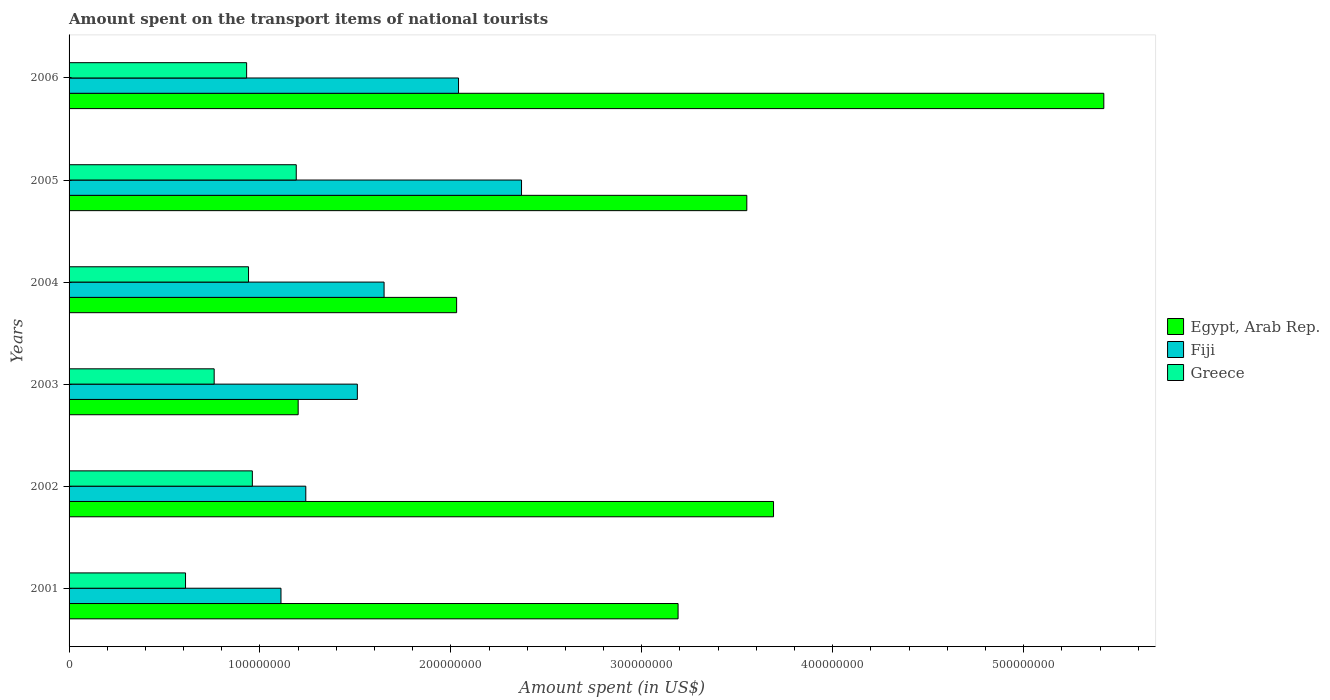How many groups of bars are there?
Provide a succinct answer. 6. How many bars are there on the 5th tick from the top?
Your answer should be compact. 3. What is the label of the 6th group of bars from the top?
Make the answer very short. 2001. What is the amount spent on the transport items of national tourists in Egypt, Arab Rep. in 2003?
Your answer should be compact. 1.20e+08. Across all years, what is the maximum amount spent on the transport items of national tourists in Egypt, Arab Rep.?
Provide a succinct answer. 5.42e+08. Across all years, what is the minimum amount spent on the transport items of national tourists in Egypt, Arab Rep.?
Provide a short and direct response. 1.20e+08. What is the total amount spent on the transport items of national tourists in Fiji in the graph?
Make the answer very short. 9.92e+08. What is the difference between the amount spent on the transport items of national tourists in Egypt, Arab Rep. in 2002 and that in 2005?
Offer a very short reply. 1.40e+07. What is the difference between the amount spent on the transport items of national tourists in Egypt, Arab Rep. in 2004 and the amount spent on the transport items of national tourists in Greece in 2002?
Provide a short and direct response. 1.07e+08. What is the average amount spent on the transport items of national tourists in Egypt, Arab Rep. per year?
Ensure brevity in your answer.  3.18e+08. In the year 2004, what is the difference between the amount spent on the transport items of national tourists in Egypt, Arab Rep. and amount spent on the transport items of national tourists in Fiji?
Ensure brevity in your answer.  3.80e+07. In how many years, is the amount spent on the transport items of national tourists in Egypt, Arab Rep. greater than 40000000 US$?
Provide a short and direct response. 6. What is the ratio of the amount spent on the transport items of national tourists in Egypt, Arab Rep. in 2003 to that in 2005?
Give a very brief answer. 0.34. Is the amount spent on the transport items of national tourists in Fiji in 2003 less than that in 2004?
Keep it short and to the point. Yes. What is the difference between the highest and the second highest amount spent on the transport items of national tourists in Greece?
Keep it short and to the point. 2.30e+07. What is the difference between the highest and the lowest amount spent on the transport items of national tourists in Greece?
Provide a short and direct response. 5.80e+07. In how many years, is the amount spent on the transport items of national tourists in Fiji greater than the average amount spent on the transport items of national tourists in Fiji taken over all years?
Your response must be concise. 2. What does the 3rd bar from the top in 2005 represents?
Your response must be concise. Egypt, Arab Rep. What does the 2nd bar from the bottom in 2001 represents?
Your answer should be compact. Fiji. Are all the bars in the graph horizontal?
Make the answer very short. Yes. How many years are there in the graph?
Offer a terse response. 6. Does the graph contain any zero values?
Give a very brief answer. No. Does the graph contain grids?
Ensure brevity in your answer.  No. Where does the legend appear in the graph?
Ensure brevity in your answer.  Center right. What is the title of the graph?
Make the answer very short. Amount spent on the transport items of national tourists. Does "Georgia" appear as one of the legend labels in the graph?
Offer a very short reply. No. What is the label or title of the X-axis?
Your answer should be compact. Amount spent (in US$). What is the Amount spent (in US$) in Egypt, Arab Rep. in 2001?
Ensure brevity in your answer.  3.19e+08. What is the Amount spent (in US$) of Fiji in 2001?
Offer a very short reply. 1.11e+08. What is the Amount spent (in US$) in Greece in 2001?
Offer a very short reply. 6.10e+07. What is the Amount spent (in US$) of Egypt, Arab Rep. in 2002?
Make the answer very short. 3.69e+08. What is the Amount spent (in US$) of Fiji in 2002?
Your answer should be very brief. 1.24e+08. What is the Amount spent (in US$) in Greece in 2002?
Give a very brief answer. 9.60e+07. What is the Amount spent (in US$) in Egypt, Arab Rep. in 2003?
Your answer should be compact. 1.20e+08. What is the Amount spent (in US$) in Fiji in 2003?
Your answer should be very brief. 1.51e+08. What is the Amount spent (in US$) of Greece in 2003?
Offer a terse response. 7.60e+07. What is the Amount spent (in US$) in Egypt, Arab Rep. in 2004?
Your answer should be very brief. 2.03e+08. What is the Amount spent (in US$) in Fiji in 2004?
Your response must be concise. 1.65e+08. What is the Amount spent (in US$) of Greece in 2004?
Your answer should be very brief. 9.40e+07. What is the Amount spent (in US$) of Egypt, Arab Rep. in 2005?
Ensure brevity in your answer.  3.55e+08. What is the Amount spent (in US$) of Fiji in 2005?
Keep it short and to the point. 2.37e+08. What is the Amount spent (in US$) of Greece in 2005?
Keep it short and to the point. 1.19e+08. What is the Amount spent (in US$) of Egypt, Arab Rep. in 2006?
Your response must be concise. 5.42e+08. What is the Amount spent (in US$) in Fiji in 2006?
Provide a succinct answer. 2.04e+08. What is the Amount spent (in US$) in Greece in 2006?
Keep it short and to the point. 9.30e+07. Across all years, what is the maximum Amount spent (in US$) in Egypt, Arab Rep.?
Provide a short and direct response. 5.42e+08. Across all years, what is the maximum Amount spent (in US$) in Fiji?
Ensure brevity in your answer.  2.37e+08. Across all years, what is the maximum Amount spent (in US$) of Greece?
Keep it short and to the point. 1.19e+08. Across all years, what is the minimum Amount spent (in US$) of Egypt, Arab Rep.?
Provide a short and direct response. 1.20e+08. Across all years, what is the minimum Amount spent (in US$) in Fiji?
Your answer should be compact. 1.11e+08. Across all years, what is the minimum Amount spent (in US$) in Greece?
Your answer should be very brief. 6.10e+07. What is the total Amount spent (in US$) in Egypt, Arab Rep. in the graph?
Make the answer very short. 1.91e+09. What is the total Amount spent (in US$) of Fiji in the graph?
Offer a very short reply. 9.92e+08. What is the total Amount spent (in US$) in Greece in the graph?
Offer a terse response. 5.39e+08. What is the difference between the Amount spent (in US$) of Egypt, Arab Rep. in 2001 and that in 2002?
Keep it short and to the point. -5.00e+07. What is the difference between the Amount spent (in US$) of Fiji in 2001 and that in 2002?
Make the answer very short. -1.30e+07. What is the difference between the Amount spent (in US$) in Greece in 2001 and that in 2002?
Give a very brief answer. -3.50e+07. What is the difference between the Amount spent (in US$) of Egypt, Arab Rep. in 2001 and that in 2003?
Your response must be concise. 1.99e+08. What is the difference between the Amount spent (in US$) in Fiji in 2001 and that in 2003?
Give a very brief answer. -4.00e+07. What is the difference between the Amount spent (in US$) in Greece in 2001 and that in 2003?
Ensure brevity in your answer.  -1.50e+07. What is the difference between the Amount spent (in US$) in Egypt, Arab Rep. in 2001 and that in 2004?
Keep it short and to the point. 1.16e+08. What is the difference between the Amount spent (in US$) of Fiji in 2001 and that in 2004?
Give a very brief answer. -5.40e+07. What is the difference between the Amount spent (in US$) of Greece in 2001 and that in 2004?
Offer a very short reply. -3.30e+07. What is the difference between the Amount spent (in US$) in Egypt, Arab Rep. in 2001 and that in 2005?
Your answer should be compact. -3.60e+07. What is the difference between the Amount spent (in US$) in Fiji in 2001 and that in 2005?
Offer a very short reply. -1.26e+08. What is the difference between the Amount spent (in US$) of Greece in 2001 and that in 2005?
Your answer should be compact. -5.80e+07. What is the difference between the Amount spent (in US$) of Egypt, Arab Rep. in 2001 and that in 2006?
Make the answer very short. -2.23e+08. What is the difference between the Amount spent (in US$) in Fiji in 2001 and that in 2006?
Make the answer very short. -9.30e+07. What is the difference between the Amount spent (in US$) in Greece in 2001 and that in 2006?
Make the answer very short. -3.20e+07. What is the difference between the Amount spent (in US$) in Egypt, Arab Rep. in 2002 and that in 2003?
Make the answer very short. 2.49e+08. What is the difference between the Amount spent (in US$) in Fiji in 2002 and that in 2003?
Give a very brief answer. -2.70e+07. What is the difference between the Amount spent (in US$) of Greece in 2002 and that in 2003?
Offer a terse response. 2.00e+07. What is the difference between the Amount spent (in US$) of Egypt, Arab Rep. in 2002 and that in 2004?
Provide a short and direct response. 1.66e+08. What is the difference between the Amount spent (in US$) in Fiji in 2002 and that in 2004?
Make the answer very short. -4.10e+07. What is the difference between the Amount spent (in US$) of Greece in 2002 and that in 2004?
Offer a very short reply. 2.00e+06. What is the difference between the Amount spent (in US$) of Egypt, Arab Rep. in 2002 and that in 2005?
Your response must be concise. 1.40e+07. What is the difference between the Amount spent (in US$) in Fiji in 2002 and that in 2005?
Provide a succinct answer. -1.13e+08. What is the difference between the Amount spent (in US$) of Greece in 2002 and that in 2005?
Provide a short and direct response. -2.30e+07. What is the difference between the Amount spent (in US$) in Egypt, Arab Rep. in 2002 and that in 2006?
Make the answer very short. -1.73e+08. What is the difference between the Amount spent (in US$) in Fiji in 2002 and that in 2006?
Offer a very short reply. -8.00e+07. What is the difference between the Amount spent (in US$) of Egypt, Arab Rep. in 2003 and that in 2004?
Your response must be concise. -8.30e+07. What is the difference between the Amount spent (in US$) of Fiji in 2003 and that in 2004?
Make the answer very short. -1.40e+07. What is the difference between the Amount spent (in US$) of Greece in 2003 and that in 2004?
Offer a terse response. -1.80e+07. What is the difference between the Amount spent (in US$) in Egypt, Arab Rep. in 2003 and that in 2005?
Your response must be concise. -2.35e+08. What is the difference between the Amount spent (in US$) in Fiji in 2003 and that in 2005?
Make the answer very short. -8.60e+07. What is the difference between the Amount spent (in US$) of Greece in 2003 and that in 2005?
Your answer should be compact. -4.30e+07. What is the difference between the Amount spent (in US$) in Egypt, Arab Rep. in 2003 and that in 2006?
Provide a succinct answer. -4.22e+08. What is the difference between the Amount spent (in US$) in Fiji in 2003 and that in 2006?
Your answer should be very brief. -5.30e+07. What is the difference between the Amount spent (in US$) in Greece in 2003 and that in 2006?
Your response must be concise. -1.70e+07. What is the difference between the Amount spent (in US$) in Egypt, Arab Rep. in 2004 and that in 2005?
Give a very brief answer. -1.52e+08. What is the difference between the Amount spent (in US$) of Fiji in 2004 and that in 2005?
Ensure brevity in your answer.  -7.20e+07. What is the difference between the Amount spent (in US$) of Greece in 2004 and that in 2005?
Provide a short and direct response. -2.50e+07. What is the difference between the Amount spent (in US$) in Egypt, Arab Rep. in 2004 and that in 2006?
Your answer should be compact. -3.39e+08. What is the difference between the Amount spent (in US$) of Fiji in 2004 and that in 2006?
Your answer should be very brief. -3.90e+07. What is the difference between the Amount spent (in US$) of Egypt, Arab Rep. in 2005 and that in 2006?
Offer a very short reply. -1.87e+08. What is the difference between the Amount spent (in US$) in Fiji in 2005 and that in 2006?
Keep it short and to the point. 3.30e+07. What is the difference between the Amount spent (in US$) in Greece in 2005 and that in 2006?
Your answer should be very brief. 2.60e+07. What is the difference between the Amount spent (in US$) of Egypt, Arab Rep. in 2001 and the Amount spent (in US$) of Fiji in 2002?
Your answer should be compact. 1.95e+08. What is the difference between the Amount spent (in US$) in Egypt, Arab Rep. in 2001 and the Amount spent (in US$) in Greece in 2002?
Offer a very short reply. 2.23e+08. What is the difference between the Amount spent (in US$) in Fiji in 2001 and the Amount spent (in US$) in Greece in 2002?
Provide a short and direct response. 1.50e+07. What is the difference between the Amount spent (in US$) in Egypt, Arab Rep. in 2001 and the Amount spent (in US$) in Fiji in 2003?
Give a very brief answer. 1.68e+08. What is the difference between the Amount spent (in US$) of Egypt, Arab Rep. in 2001 and the Amount spent (in US$) of Greece in 2003?
Your answer should be compact. 2.43e+08. What is the difference between the Amount spent (in US$) in Fiji in 2001 and the Amount spent (in US$) in Greece in 2003?
Ensure brevity in your answer.  3.50e+07. What is the difference between the Amount spent (in US$) in Egypt, Arab Rep. in 2001 and the Amount spent (in US$) in Fiji in 2004?
Give a very brief answer. 1.54e+08. What is the difference between the Amount spent (in US$) of Egypt, Arab Rep. in 2001 and the Amount spent (in US$) of Greece in 2004?
Provide a succinct answer. 2.25e+08. What is the difference between the Amount spent (in US$) in Fiji in 2001 and the Amount spent (in US$) in Greece in 2004?
Make the answer very short. 1.70e+07. What is the difference between the Amount spent (in US$) of Egypt, Arab Rep. in 2001 and the Amount spent (in US$) of Fiji in 2005?
Your response must be concise. 8.20e+07. What is the difference between the Amount spent (in US$) in Fiji in 2001 and the Amount spent (in US$) in Greece in 2005?
Provide a succinct answer. -8.00e+06. What is the difference between the Amount spent (in US$) of Egypt, Arab Rep. in 2001 and the Amount spent (in US$) of Fiji in 2006?
Offer a terse response. 1.15e+08. What is the difference between the Amount spent (in US$) in Egypt, Arab Rep. in 2001 and the Amount spent (in US$) in Greece in 2006?
Your answer should be compact. 2.26e+08. What is the difference between the Amount spent (in US$) in Fiji in 2001 and the Amount spent (in US$) in Greece in 2006?
Offer a very short reply. 1.80e+07. What is the difference between the Amount spent (in US$) in Egypt, Arab Rep. in 2002 and the Amount spent (in US$) in Fiji in 2003?
Keep it short and to the point. 2.18e+08. What is the difference between the Amount spent (in US$) in Egypt, Arab Rep. in 2002 and the Amount spent (in US$) in Greece in 2003?
Provide a short and direct response. 2.93e+08. What is the difference between the Amount spent (in US$) of Fiji in 2002 and the Amount spent (in US$) of Greece in 2003?
Your answer should be very brief. 4.80e+07. What is the difference between the Amount spent (in US$) in Egypt, Arab Rep. in 2002 and the Amount spent (in US$) in Fiji in 2004?
Offer a very short reply. 2.04e+08. What is the difference between the Amount spent (in US$) in Egypt, Arab Rep. in 2002 and the Amount spent (in US$) in Greece in 2004?
Your answer should be compact. 2.75e+08. What is the difference between the Amount spent (in US$) in Fiji in 2002 and the Amount spent (in US$) in Greece in 2004?
Make the answer very short. 3.00e+07. What is the difference between the Amount spent (in US$) in Egypt, Arab Rep. in 2002 and the Amount spent (in US$) in Fiji in 2005?
Give a very brief answer. 1.32e+08. What is the difference between the Amount spent (in US$) of Egypt, Arab Rep. in 2002 and the Amount spent (in US$) of Greece in 2005?
Offer a terse response. 2.50e+08. What is the difference between the Amount spent (in US$) of Egypt, Arab Rep. in 2002 and the Amount spent (in US$) of Fiji in 2006?
Keep it short and to the point. 1.65e+08. What is the difference between the Amount spent (in US$) in Egypt, Arab Rep. in 2002 and the Amount spent (in US$) in Greece in 2006?
Your response must be concise. 2.76e+08. What is the difference between the Amount spent (in US$) in Fiji in 2002 and the Amount spent (in US$) in Greece in 2006?
Offer a terse response. 3.10e+07. What is the difference between the Amount spent (in US$) in Egypt, Arab Rep. in 2003 and the Amount spent (in US$) in Fiji in 2004?
Give a very brief answer. -4.50e+07. What is the difference between the Amount spent (in US$) in Egypt, Arab Rep. in 2003 and the Amount spent (in US$) in Greece in 2004?
Your answer should be compact. 2.60e+07. What is the difference between the Amount spent (in US$) in Fiji in 2003 and the Amount spent (in US$) in Greece in 2004?
Keep it short and to the point. 5.70e+07. What is the difference between the Amount spent (in US$) in Egypt, Arab Rep. in 2003 and the Amount spent (in US$) in Fiji in 2005?
Provide a succinct answer. -1.17e+08. What is the difference between the Amount spent (in US$) of Egypt, Arab Rep. in 2003 and the Amount spent (in US$) of Greece in 2005?
Offer a very short reply. 1.00e+06. What is the difference between the Amount spent (in US$) of Fiji in 2003 and the Amount spent (in US$) of Greece in 2005?
Ensure brevity in your answer.  3.20e+07. What is the difference between the Amount spent (in US$) of Egypt, Arab Rep. in 2003 and the Amount spent (in US$) of Fiji in 2006?
Your answer should be compact. -8.40e+07. What is the difference between the Amount spent (in US$) in Egypt, Arab Rep. in 2003 and the Amount spent (in US$) in Greece in 2006?
Your answer should be compact. 2.70e+07. What is the difference between the Amount spent (in US$) in Fiji in 2003 and the Amount spent (in US$) in Greece in 2006?
Ensure brevity in your answer.  5.80e+07. What is the difference between the Amount spent (in US$) of Egypt, Arab Rep. in 2004 and the Amount spent (in US$) of Fiji in 2005?
Your answer should be compact. -3.40e+07. What is the difference between the Amount spent (in US$) in Egypt, Arab Rep. in 2004 and the Amount spent (in US$) in Greece in 2005?
Provide a succinct answer. 8.40e+07. What is the difference between the Amount spent (in US$) of Fiji in 2004 and the Amount spent (in US$) of Greece in 2005?
Make the answer very short. 4.60e+07. What is the difference between the Amount spent (in US$) of Egypt, Arab Rep. in 2004 and the Amount spent (in US$) of Greece in 2006?
Offer a terse response. 1.10e+08. What is the difference between the Amount spent (in US$) of Fiji in 2004 and the Amount spent (in US$) of Greece in 2006?
Provide a succinct answer. 7.20e+07. What is the difference between the Amount spent (in US$) in Egypt, Arab Rep. in 2005 and the Amount spent (in US$) in Fiji in 2006?
Your answer should be very brief. 1.51e+08. What is the difference between the Amount spent (in US$) of Egypt, Arab Rep. in 2005 and the Amount spent (in US$) of Greece in 2006?
Keep it short and to the point. 2.62e+08. What is the difference between the Amount spent (in US$) of Fiji in 2005 and the Amount spent (in US$) of Greece in 2006?
Your response must be concise. 1.44e+08. What is the average Amount spent (in US$) in Egypt, Arab Rep. per year?
Keep it short and to the point. 3.18e+08. What is the average Amount spent (in US$) in Fiji per year?
Keep it short and to the point. 1.65e+08. What is the average Amount spent (in US$) of Greece per year?
Your answer should be very brief. 8.98e+07. In the year 2001, what is the difference between the Amount spent (in US$) of Egypt, Arab Rep. and Amount spent (in US$) of Fiji?
Your answer should be compact. 2.08e+08. In the year 2001, what is the difference between the Amount spent (in US$) in Egypt, Arab Rep. and Amount spent (in US$) in Greece?
Ensure brevity in your answer.  2.58e+08. In the year 2002, what is the difference between the Amount spent (in US$) in Egypt, Arab Rep. and Amount spent (in US$) in Fiji?
Ensure brevity in your answer.  2.45e+08. In the year 2002, what is the difference between the Amount spent (in US$) of Egypt, Arab Rep. and Amount spent (in US$) of Greece?
Offer a terse response. 2.73e+08. In the year 2002, what is the difference between the Amount spent (in US$) of Fiji and Amount spent (in US$) of Greece?
Provide a short and direct response. 2.80e+07. In the year 2003, what is the difference between the Amount spent (in US$) of Egypt, Arab Rep. and Amount spent (in US$) of Fiji?
Provide a short and direct response. -3.10e+07. In the year 2003, what is the difference between the Amount spent (in US$) of Egypt, Arab Rep. and Amount spent (in US$) of Greece?
Keep it short and to the point. 4.40e+07. In the year 2003, what is the difference between the Amount spent (in US$) in Fiji and Amount spent (in US$) in Greece?
Provide a short and direct response. 7.50e+07. In the year 2004, what is the difference between the Amount spent (in US$) in Egypt, Arab Rep. and Amount spent (in US$) in Fiji?
Give a very brief answer. 3.80e+07. In the year 2004, what is the difference between the Amount spent (in US$) in Egypt, Arab Rep. and Amount spent (in US$) in Greece?
Give a very brief answer. 1.09e+08. In the year 2004, what is the difference between the Amount spent (in US$) of Fiji and Amount spent (in US$) of Greece?
Your response must be concise. 7.10e+07. In the year 2005, what is the difference between the Amount spent (in US$) of Egypt, Arab Rep. and Amount spent (in US$) of Fiji?
Offer a terse response. 1.18e+08. In the year 2005, what is the difference between the Amount spent (in US$) of Egypt, Arab Rep. and Amount spent (in US$) of Greece?
Your answer should be compact. 2.36e+08. In the year 2005, what is the difference between the Amount spent (in US$) of Fiji and Amount spent (in US$) of Greece?
Your answer should be compact. 1.18e+08. In the year 2006, what is the difference between the Amount spent (in US$) in Egypt, Arab Rep. and Amount spent (in US$) in Fiji?
Your answer should be very brief. 3.38e+08. In the year 2006, what is the difference between the Amount spent (in US$) in Egypt, Arab Rep. and Amount spent (in US$) in Greece?
Provide a succinct answer. 4.49e+08. In the year 2006, what is the difference between the Amount spent (in US$) of Fiji and Amount spent (in US$) of Greece?
Your answer should be compact. 1.11e+08. What is the ratio of the Amount spent (in US$) in Egypt, Arab Rep. in 2001 to that in 2002?
Provide a succinct answer. 0.86. What is the ratio of the Amount spent (in US$) in Fiji in 2001 to that in 2002?
Provide a short and direct response. 0.9. What is the ratio of the Amount spent (in US$) of Greece in 2001 to that in 2002?
Keep it short and to the point. 0.64. What is the ratio of the Amount spent (in US$) in Egypt, Arab Rep. in 2001 to that in 2003?
Your answer should be very brief. 2.66. What is the ratio of the Amount spent (in US$) in Fiji in 2001 to that in 2003?
Your response must be concise. 0.74. What is the ratio of the Amount spent (in US$) of Greece in 2001 to that in 2003?
Your response must be concise. 0.8. What is the ratio of the Amount spent (in US$) of Egypt, Arab Rep. in 2001 to that in 2004?
Your response must be concise. 1.57. What is the ratio of the Amount spent (in US$) in Fiji in 2001 to that in 2004?
Your response must be concise. 0.67. What is the ratio of the Amount spent (in US$) of Greece in 2001 to that in 2004?
Your answer should be compact. 0.65. What is the ratio of the Amount spent (in US$) in Egypt, Arab Rep. in 2001 to that in 2005?
Ensure brevity in your answer.  0.9. What is the ratio of the Amount spent (in US$) in Fiji in 2001 to that in 2005?
Ensure brevity in your answer.  0.47. What is the ratio of the Amount spent (in US$) of Greece in 2001 to that in 2005?
Make the answer very short. 0.51. What is the ratio of the Amount spent (in US$) of Egypt, Arab Rep. in 2001 to that in 2006?
Provide a short and direct response. 0.59. What is the ratio of the Amount spent (in US$) of Fiji in 2001 to that in 2006?
Make the answer very short. 0.54. What is the ratio of the Amount spent (in US$) in Greece in 2001 to that in 2006?
Your answer should be compact. 0.66. What is the ratio of the Amount spent (in US$) in Egypt, Arab Rep. in 2002 to that in 2003?
Your answer should be compact. 3.08. What is the ratio of the Amount spent (in US$) of Fiji in 2002 to that in 2003?
Make the answer very short. 0.82. What is the ratio of the Amount spent (in US$) of Greece in 2002 to that in 2003?
Provide a short and direct response. 1.26. What is the ratio of the Amount spent (in US$) in Egypt, Arab Rep. in 2002 to that in 2004?
Your answer should be compact. 1.82. What is the ratio of the Amount spent (in US$) of Fiji in 2002 to that in 2004?
Your response must be concise. 0.75. What is the ratio of the Amount spent (in US$) of Greece in 2002 to that in 2004?
Offer a very short reply. 1.02. What is the ratio of the Amount spent (in US$) in Egypt, Arab Rep. in 2002 to that in 2005?
Your answer should be very brief. 1.04. What is the ratio of the Amount spent (in US$) of Fiji in 2002 to that in 2005?
Provide a succinct answer. 0.52. What is the ratio of the Amount spent (in US$) of Greece in 2002 to that in 2005?
Provide a short and direct response. 0.81. What is the ratio of the Amount spent (in US$) in Egypt, Arab Rep. in 2002 to that in 2006?
Provide a succinct answer. 0.68. What is the ratio of the Amount spent (in US$) of Fiji in 2002 to that in 2006?
Offer a very short reply. 0.61. What is the ratio of the Amount spent (in US$) of Greece in 2002 to that in 2006?
Your answer should be compact. 1.03. What is the ratio of the Amount spent (in US$) of Egypt, Arab Rep. in 2003 to that in 2004?
Ensure brevity in your answer.  0.59. What is the ratio of the Amount spent (in US$) in Fiji in 2003 to that in 2004?
Make the answer very short. 0.92. What is the ratio of the Amount spent (in US$) of Greece in 2003 to that in 2004?
Your response must be concise. 0.81. What is the ratio of the Amount spent (in US$) of Egypt, Arab Rep. in 2003 to that in 2005?
Provide a short and direct response. 0.34. What is the ratio of the Amount spent (in US$) of Fiji in 2003 to that in 2005?
Keep it short and to the point. 0.64. What is the ratio of the Amount spent (in US$) in Greece in 2003 to that in 2005?
Keep it short and to the point. 0.64. What is the ratio of the Amount spent (in US$) of Egypt, Arab Rep. in 2003 to that in 2006?
Offer a very short reply. 0.22. What is the ratio of the Amount spent (in US$) in Fiji in 2003 to that in 2006?
Make the answer very short. 0.74. What is the ratio of the Amount spent (in US$) of Greece in 2003 to that in 2006?
Your response must be concise. 0.82. What is the ratio of the Amount spent (in US$) in Egypt, Arab Rep. in 2004 to that in 2005?
Give a very brief answer. 0.57. What is the ratio of the Amount spent (in US$) in Fiji in 2004 to that in 2005?
Ensure brevity in your answer.  0.7. What is the ratio of the Amount spent (in US$) in Greece in 2004 to that in 2005?
Your answer should be very brief. 0.79. What is the ratio of the Amount spent (in US$) of Egypt, Arab Rep. in 2004 to that in 2006?
Give a very brief answer. 0.37. What is the ratio of the Amount spent (in US$) of Fiji in 2004 to that in 2006?
Your answer should be compact. 0.81. What is the ratio of the Amount spent (in US$) of Greece in 2004 to that in 2006?
Provide a succinct answer. 1.01. What is the ratio of the Amount spent (in US$) of Egypt, Arab Rep. in 2005 to that in 2006?
Offer a very short reply. 0.66. What is the ratio of the Amount spent (in US$) in Fiji in 2005 to that in 2006?
Your answer should be very brief. 1.16. What is the ratio of the Amount spent (in US$) in Greece in 2005 to that in 2006?
Offer a very short reply. 1.28. What is the difference between the highest and the second highest Amount spent (in US$) in Egypt, Arab Rep.?
Your answer should be very brief. 1.73e+08. What is the difference between the highest and the second highest Amount spent (in US$) of Fiji?
Give a very brief answer. 3.30e+07. What is the difference between the highest and the second highest Amount spent (in US$) in Greece?
Make the answer very short. 2.30e+07. What is the difference between the highest and the lowest Amount spent (in US$) of Egypt, Arab Rep.?
Offer a very short reply. 4.22e+08. What is the difference between the highest and the lowest Amount spent (in US$) of Fiji?
Ensure brevity in your answer.  1.26e+08. What is the difference between the highest and the lowest Amount spent (in US$) in Greece?
Offer a very short reply. 5.80e+07. 